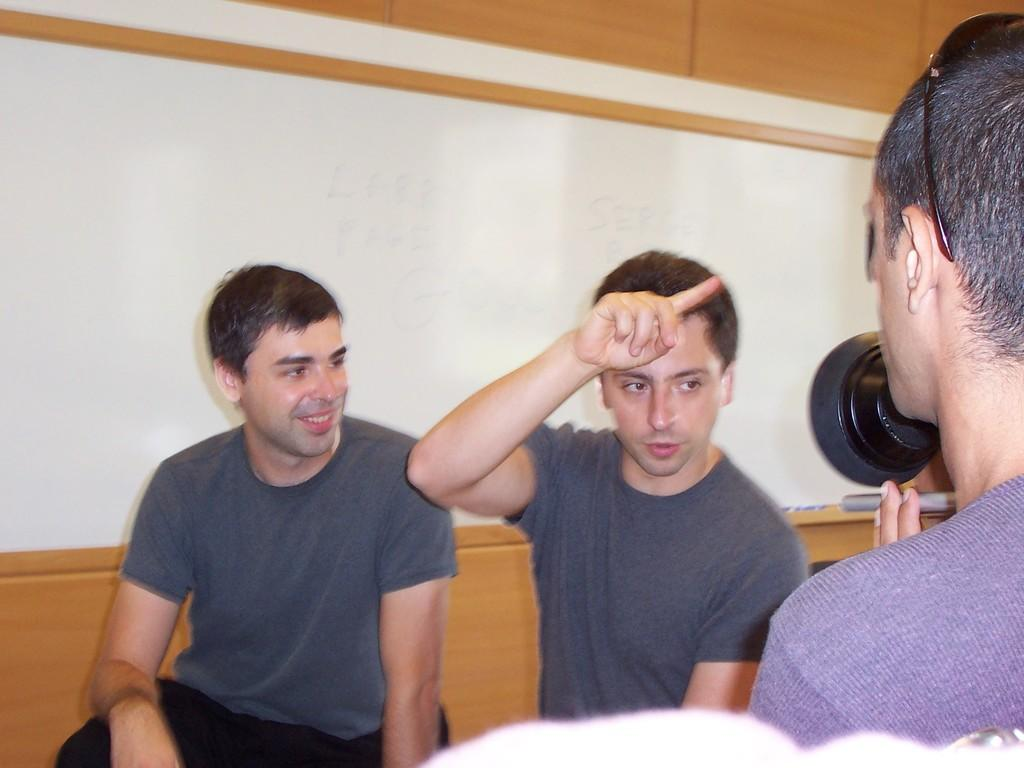How many people are sitting in the image? There are two men sitting in the image. Can you describe the person on the right side of the image? The person on the right side is holding an object in their hands. What can be seen behind the people in the image? The background of the image appears to be a wall. What type of business is being conducted on the ship in the image? There is no ship or business activity present in the image. How are the people being transported in the image? The image does not depict any form of transportation; it shows people sitting in front of a wall. 